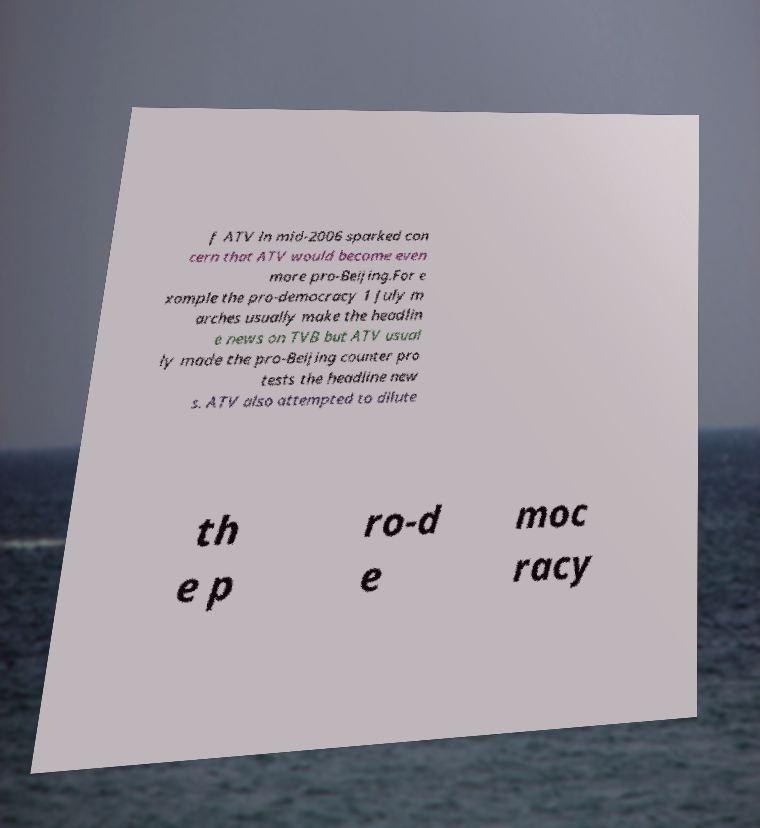Can you accurately transcribe the text from the provided image for me? f ATV in mid-2006 sparked con cern that ATV would become even more pro-Beijing.For e xample the pro-democracy 1 July m arches usually make the headlin e news on TVB but ATV usual ly made the pro-Beijing counter pro tests the headline new s. ATV also attempted to dilute th e p ro-d e moc racy 